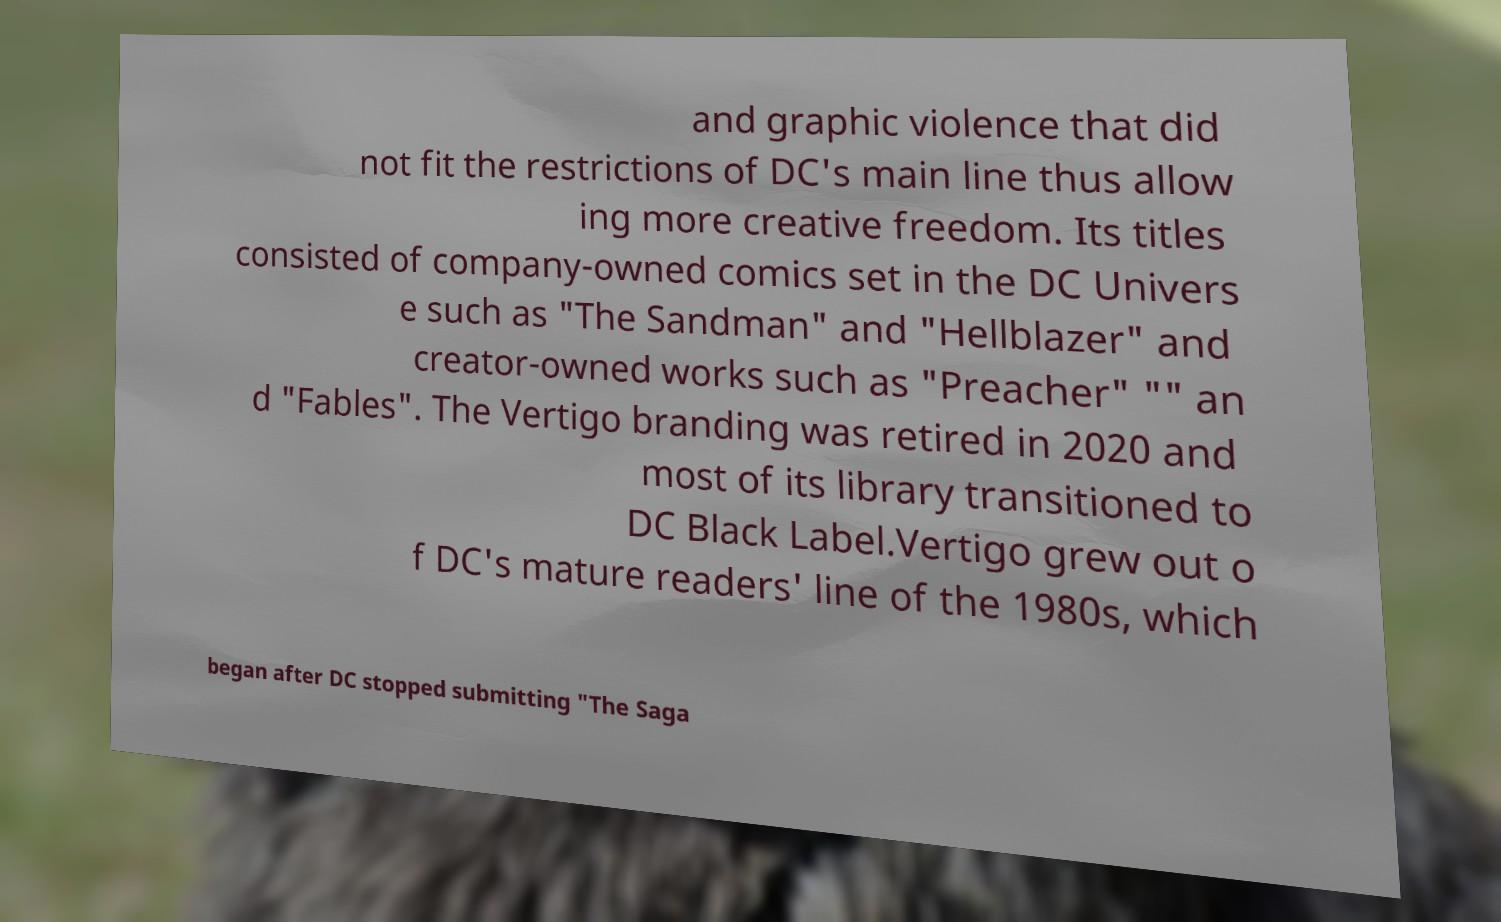What messages or text are displayed in this image? I need them in a readable, typed format. and graphic violence that did not fit the restrictions of DC's main line thus allow ing more creative freedom. Its titles consisted of company-owned comics set in the DC Univers e such as "The Sandman" and "Hellblazer" and creator-owned works such as "Preacher" "" an d "Fables". The Vertigo branding was retired in 2020 and most of its library transitioned to DC Black Label.Vertigo grew out o f DC's mature readers' line of the 1980s, which began after DC stopped submitting "The Saga 